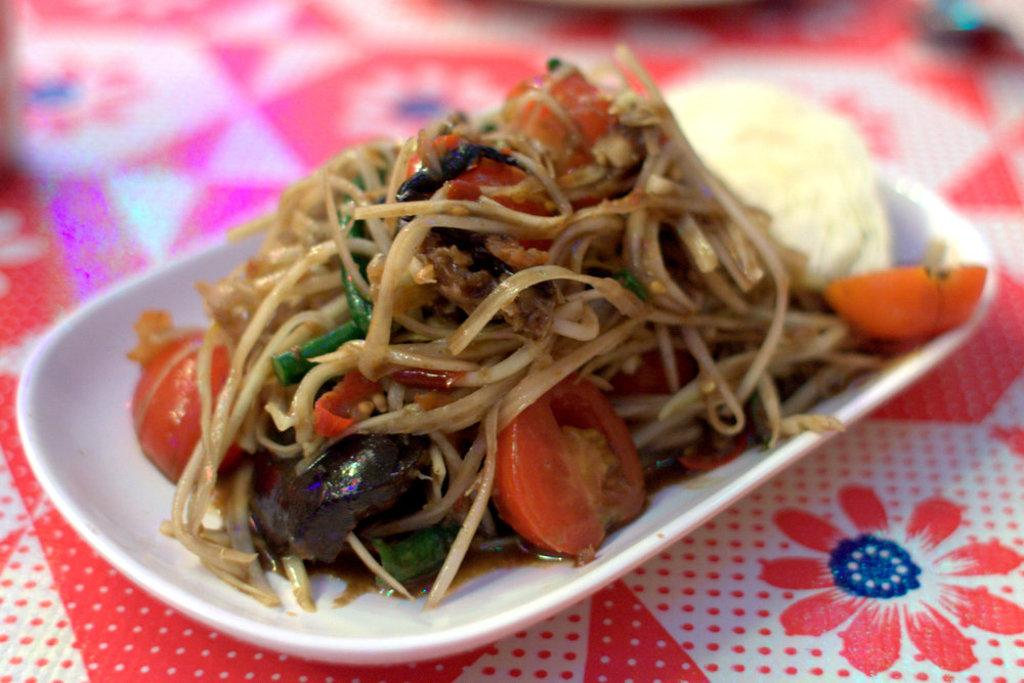What is the main object in the image? There is a bowl in the image. What is the bowl placed on? The bowl is on a cloth. What is inside the bowl? There is food in the bowl. Can you describe the top part of the image? The top of the image is blurred. What type of mark can be seen on the cloth in the image? There is no mention of a mark on the cloth in the provided facts, so we cannot determine if one is present. 